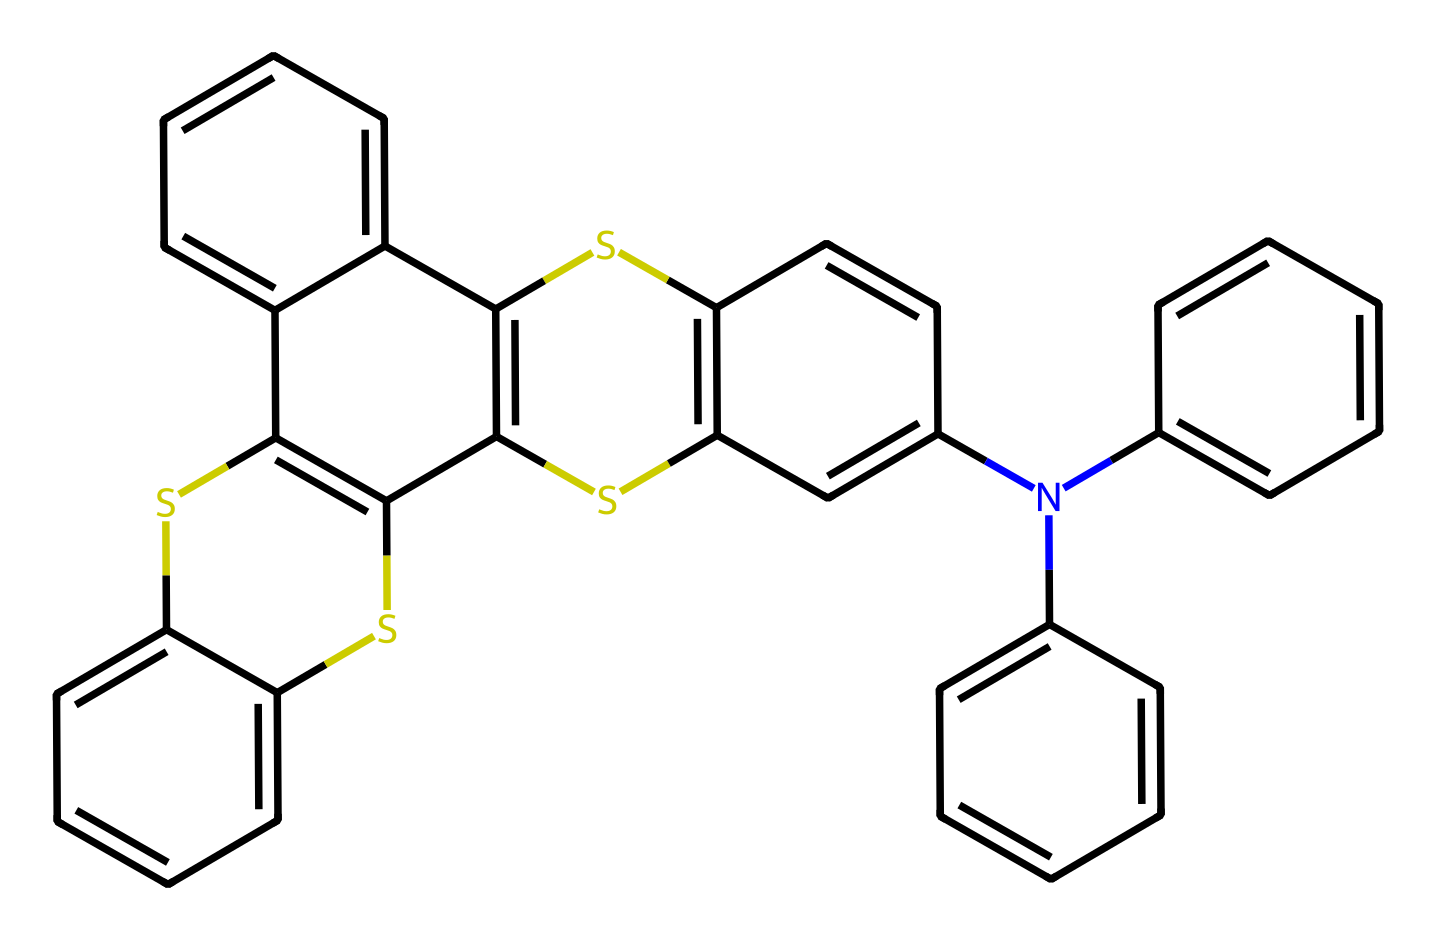What is the main type of bonding present in the chemical structure? The chemical structure primarily contains covalent bonds, evident from the shared electron pairs between atoms, including carbon and sulfur.
Answer: covalent How many sulfur atoms are present in the compound? By inspecting the structure, one can identify the distinct sulfur atoms. The SMILES representation indicates there are three sulfur atoms.
Answer: three What is the main functional group present in this compound? The presence of the sulfur atoms incorporated in the structure suggests it may belong to the thienyl functional group, often represented in aromatic compounds.
Answer: thienyl How many aromatic rings are present in the structure? By analyzing the connected carbon atoms in the structure, one can determine that there are multiple interconnected aromatic rings present. Upon careful counting, there are five aromatic rings.
Answer: five What property does the presence of sulfur contribute to the organic LED performance? Sulfur's inclusion enhances charge transport properties and optical properties, positively impacting the efficiency of organic LEDs for vibrant displays.
Answer: charge transport Does this compound exhibit any notable color properties? Typically, sulfur-containing compounds can exhibit unique color properties due to their ability to absorb certain wavelengths of light, indicating that it may contribute to display vibrancy.
Answer: yes 